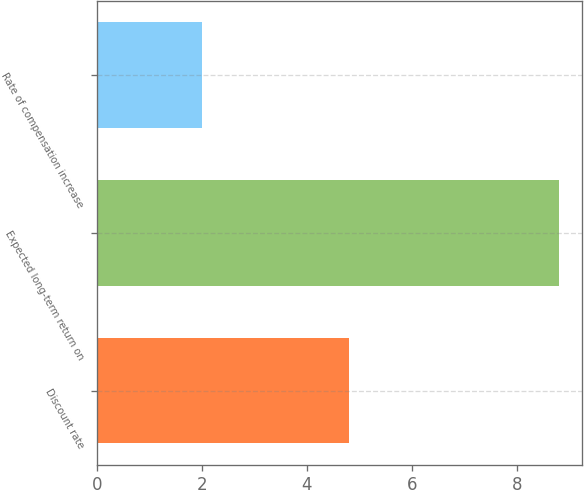Convert chart to OTSL. <chart><loc_0><loc_0><loc_500><loc_500><bar_chart><fcel>Discount rate<fcel>Expected long-term return on<fcel>Rate of compensation increase<nl><fcel>4.8<fcel>8.8<fcel>2<nl></chart> 